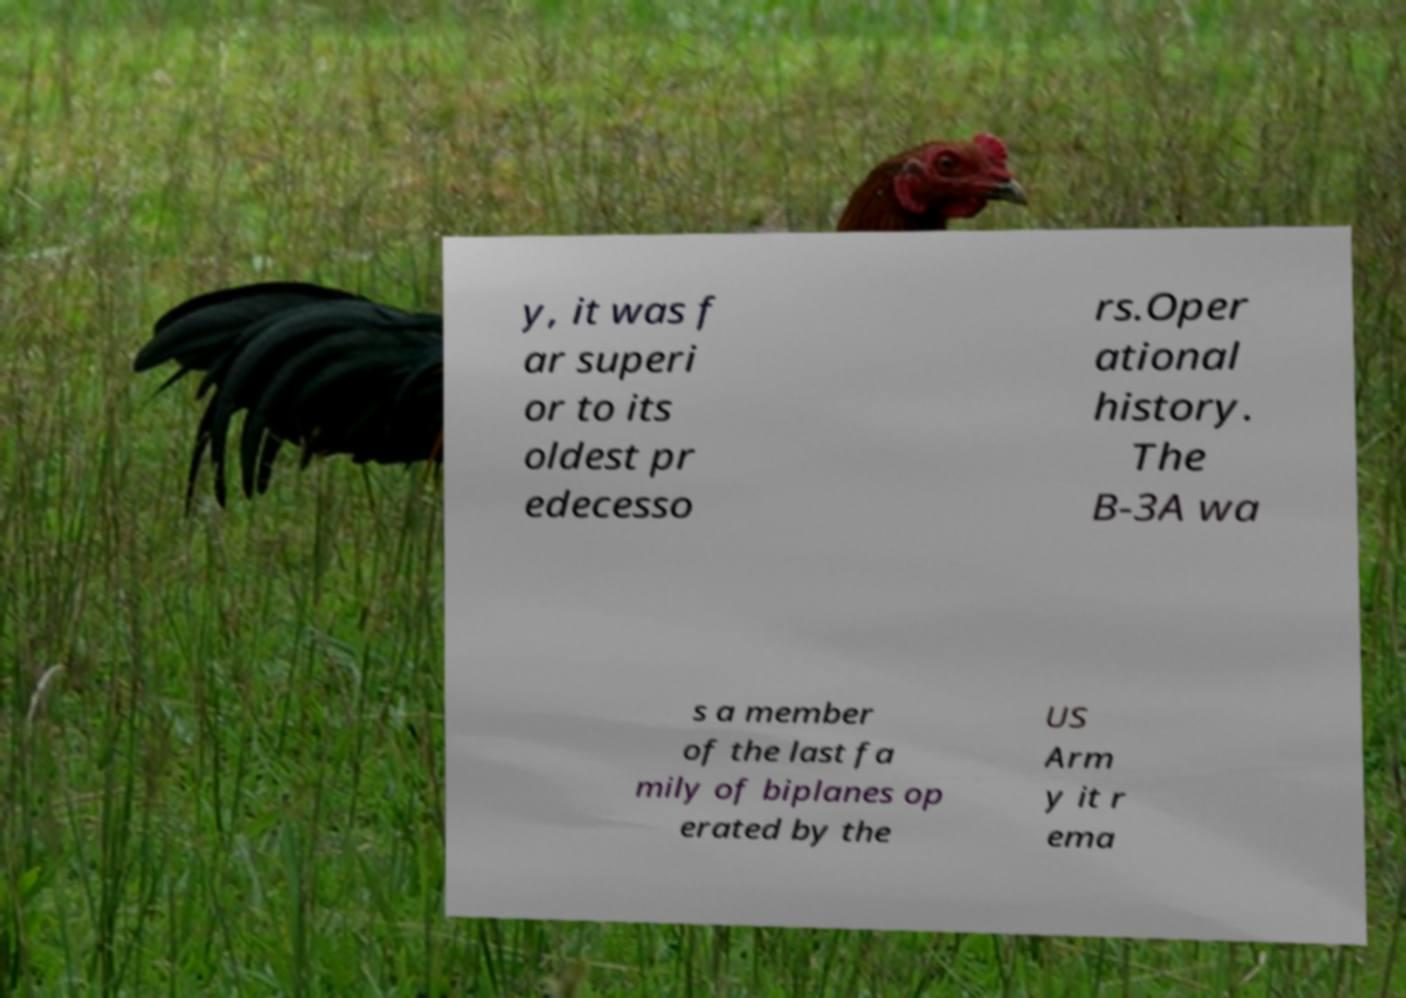Please read and relay the text visible in this image. What does it say? y, it was f ar superi or to its oldest pr edecesso rs.Oper ational history. The B-3A wa s a member of the last fa mily of biplanes op erated by the US Arm y it r ema 